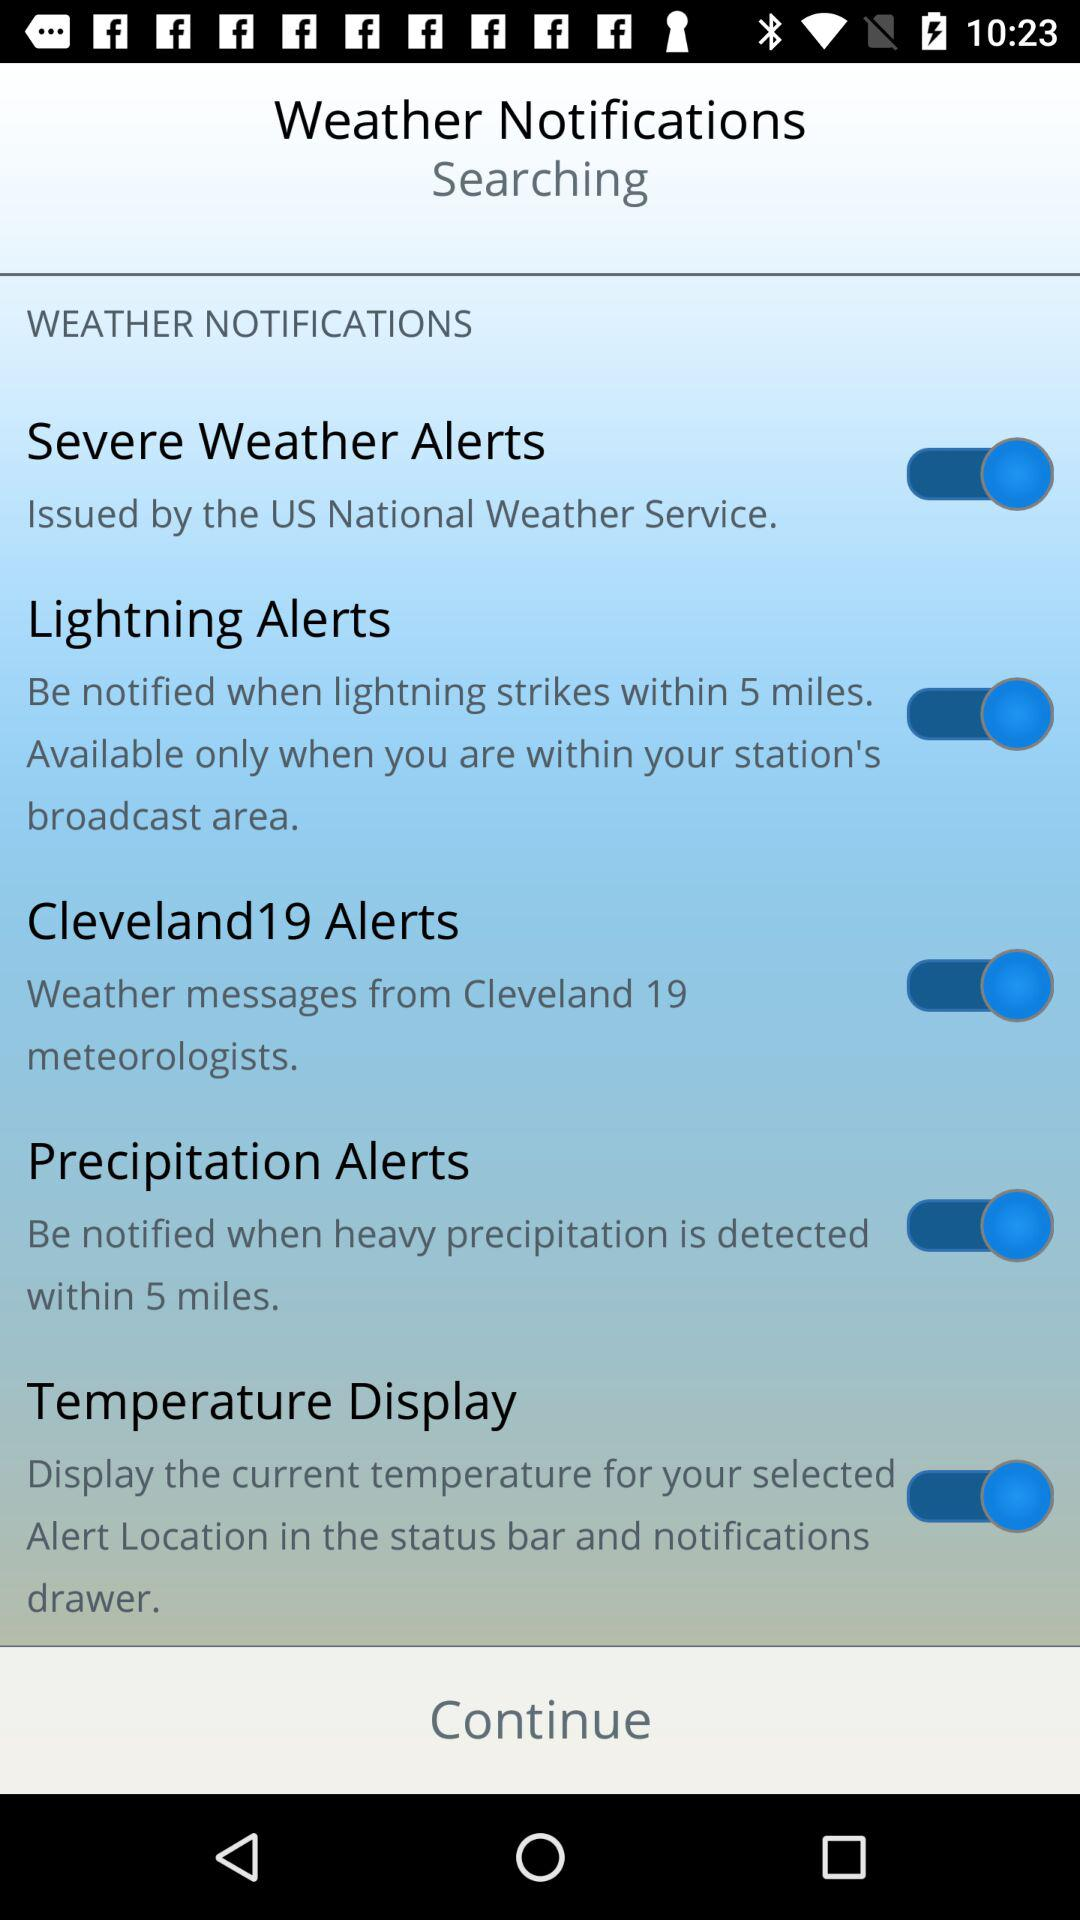How many alerts are available for the user to choose from?
Answer the question using a single word or phrase. 5 